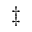Convert formula to latex. <formula><loc_0><loc_0><loc_500><loc_500>\ddag</formula> 